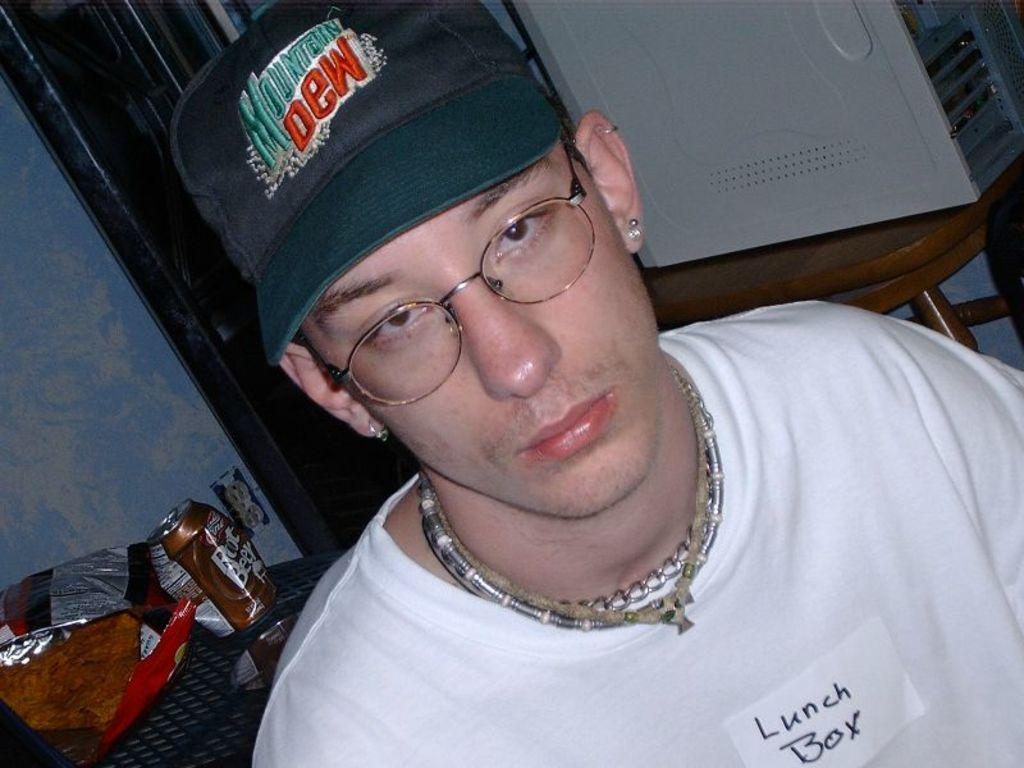How would you summarize this image in a sentence or two? The man in front of the picture wearing a white T-shirt is looking at the camera. He is wearing a cap and the spectacles. Behind him, we see a table on which coke bottle, chips packet and some other things are placed. On the right side, we see a table on which a white color thing is placed. In the background, we see a wall in blue and brown color. 